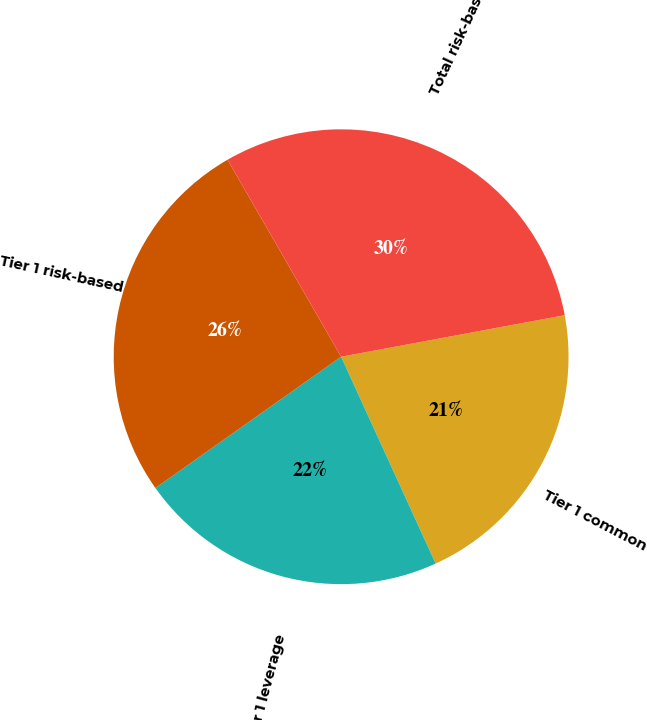Convert chart. <chart><loc_0><loc_0><loc_500><loc_500><pie_chart><fcel>Tier 1 common<fcel>Tier 1 leverage<fcel>Tier 1 risk-based<fcel>Total risk-based<nl><fcel>21.1%<fcel>22.03%<fcel>26.47%<fcel>30.4%<nl></chart> 